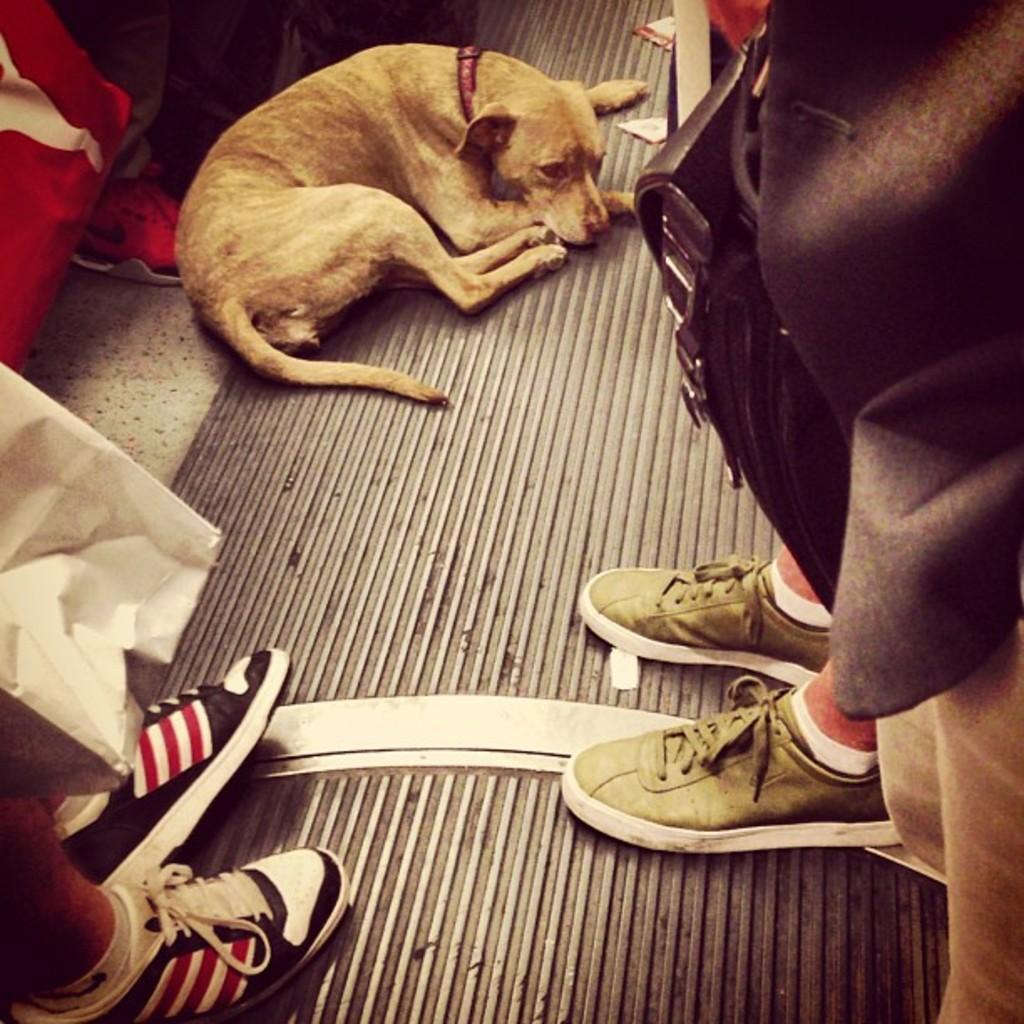Can you describe this image briefly? In this picture I can see there is a dog lying on the floor and there are few people standing around them and they are holding the bags. 